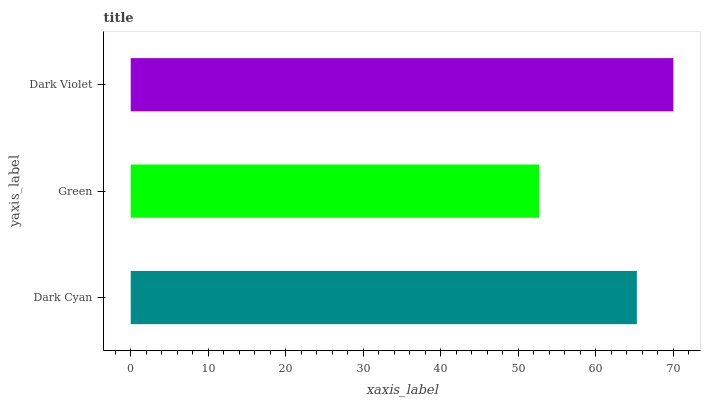Is Green the minimum?
Answer yes or no. Yes. Is Dark Violet the maximum?
Answer yes or no. Yes. Is Dark Violet the minimum?
Answer yes or no. No. Is Green the maximum?
Answer yes or no. No. Is Dark Violet greater than Green?
Answer yes or no. Yes. Is Green less than Dark Violet?
Answer yes or no. Yes. Is Green greater than Dark Violet?
Answer yes or no. No. Is Dark Violet less than Green?
Answer yes or no. No. Is Dark Cyan the high median?
Answer yes or no. Yes. Is Dark Cyan the low median?
Answer yes or no. Yes. Is Dark Violet the high median?
Answer yes or no. No. Is Green the low median?
Answer yes or no. No. 